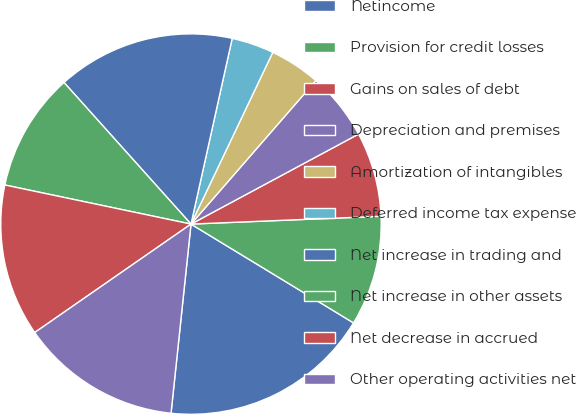Convert chart to OTSL. <chart><loc_0><loc_0><loc_500><loc_500><pie_chart><fcel>Netincome<fcel>Provision for credit losses<fcel>Gains on sales of debt<fcel>Depreciation and premises<fcel>Amortization of intangibles<fcel>Deferred income tax expense<fcel>Net increase in trading and<fcel>Net increase in other assets<fcel>Net decrease in accrued<fcel>Other operating activities net<nl><fcel>17.98%<fcel>9.35%<fcel>7.19%<fcel>5.76%<fcel>4.32%<fcel>3.6%<fcel>15.11%<fcel>10.07%<fcel>12.95%<fcel>13.67%<nl></chart> 